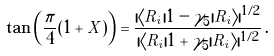<formula> <loc_0><loc_0><loc_500><loc_500>\tan \left ( \frac { \pi } { 4 } ( 1 + X ) \right ) = \frac { | \langle R _ { i } | 1 - \gamma _ { 5 } | R _ { i } \rangle | ^ { 1 / 2 } } { | \langle R _ { i } | 1 + \gamma _ { 5 } | R _ { i } \rangle | ^ { 1 / 2 } } \, .</formula> 